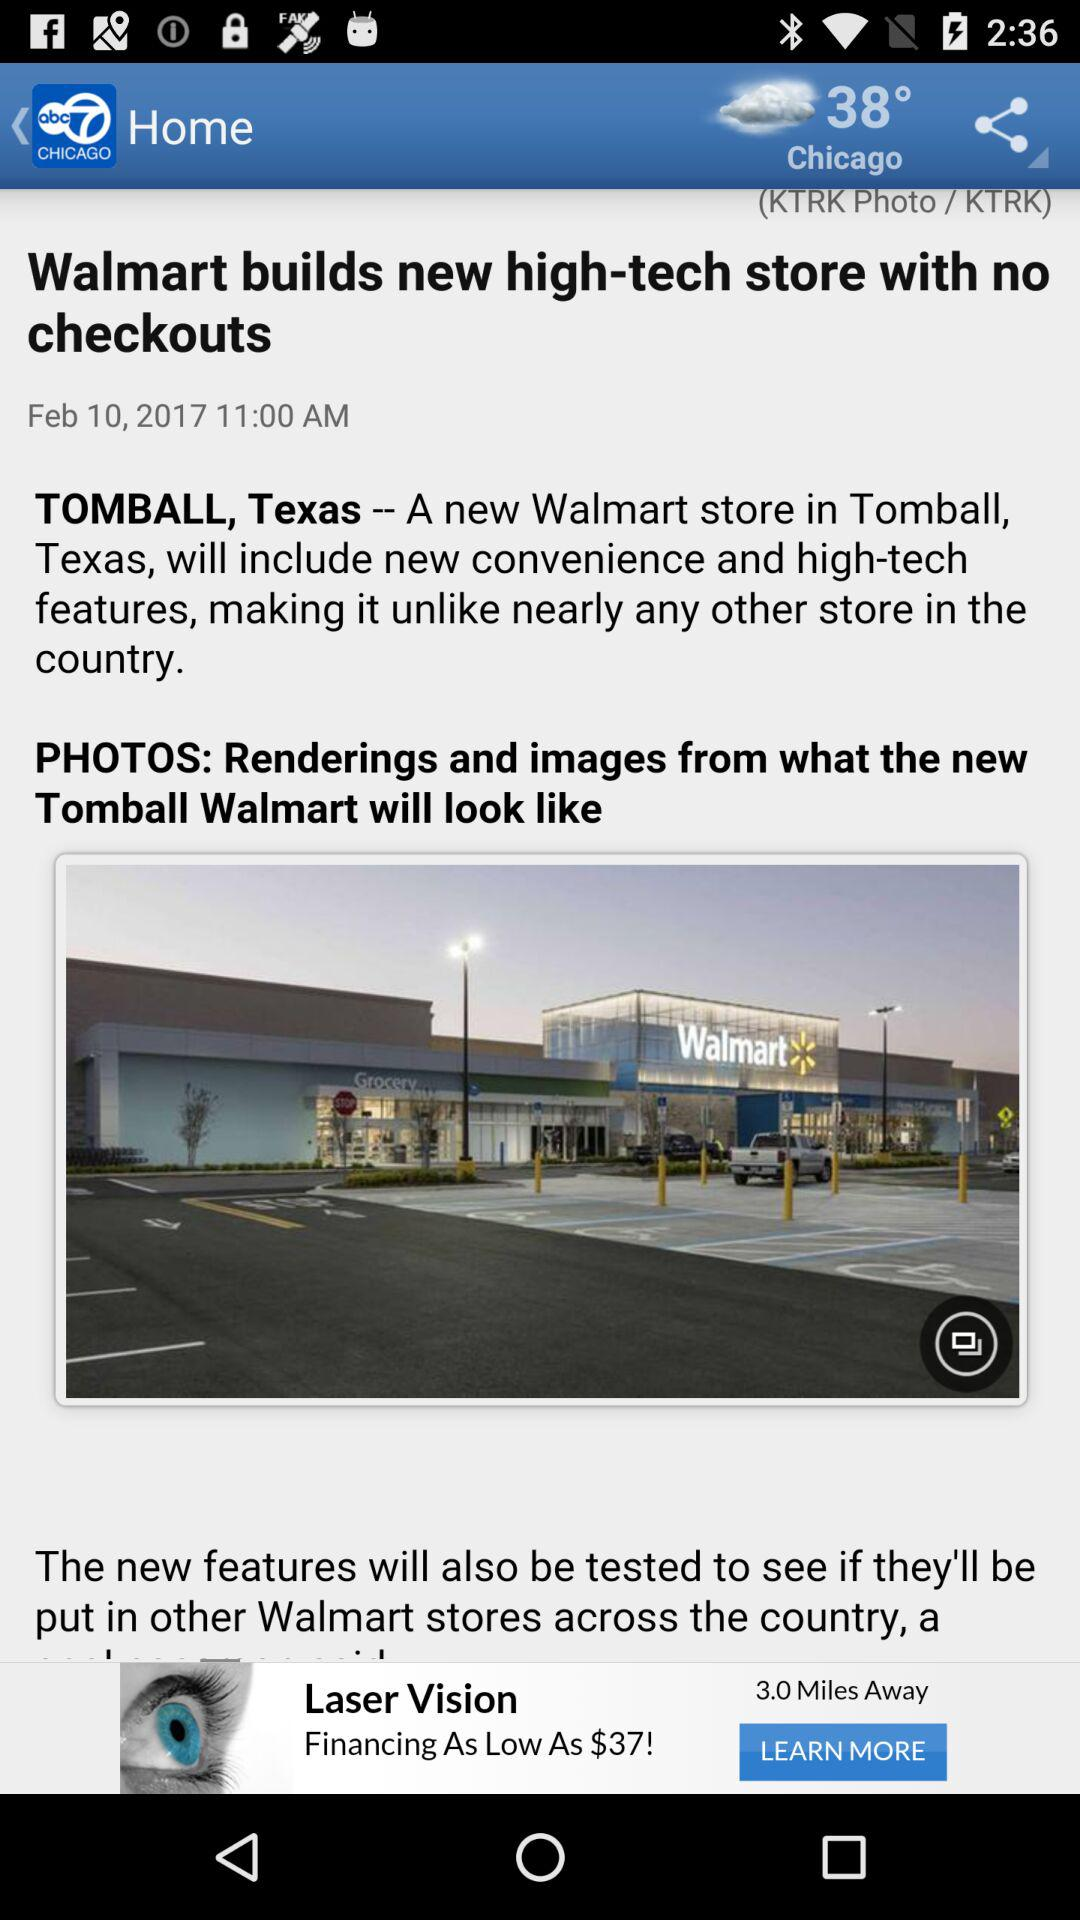What is the date? The date is February 10, 2017. 